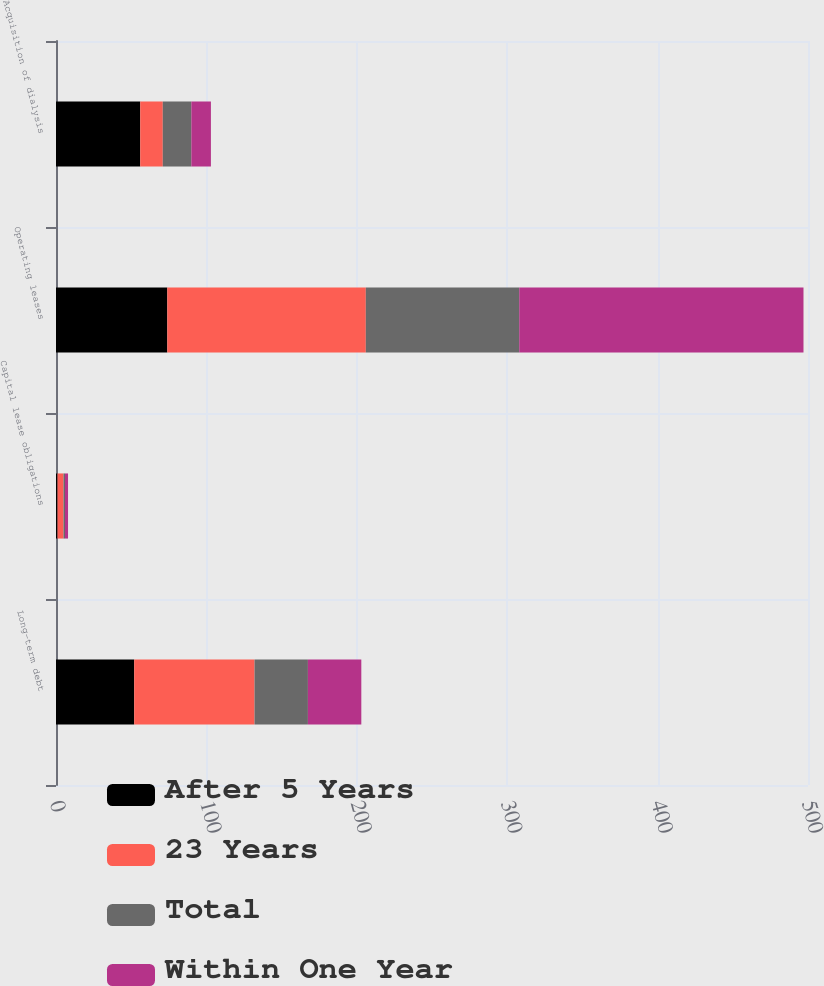Convert chart. <chart><loc_0><loc_0><loc_500><loc_500><stacked_bar_chart><ecel><fcel>Long-term debt<fcel>Capital lease obligations<fcel>Operating leases<fcel>Acquisition of dialysis<nl><fcel>After 5 Years<fcel>52<fcel>1<fcel>74<fcel>56<nl><fcel>23 Years<fcel>80<fcel>4<fcel>132<fcel>15<nl><fcel>Total<fcel>35.5<fcel>1<fcel>102<fcel>19<nl><fcel>Within One Year<fcel>35.5<fcel>2<fcel>189<fcel>13<nl></chart> 